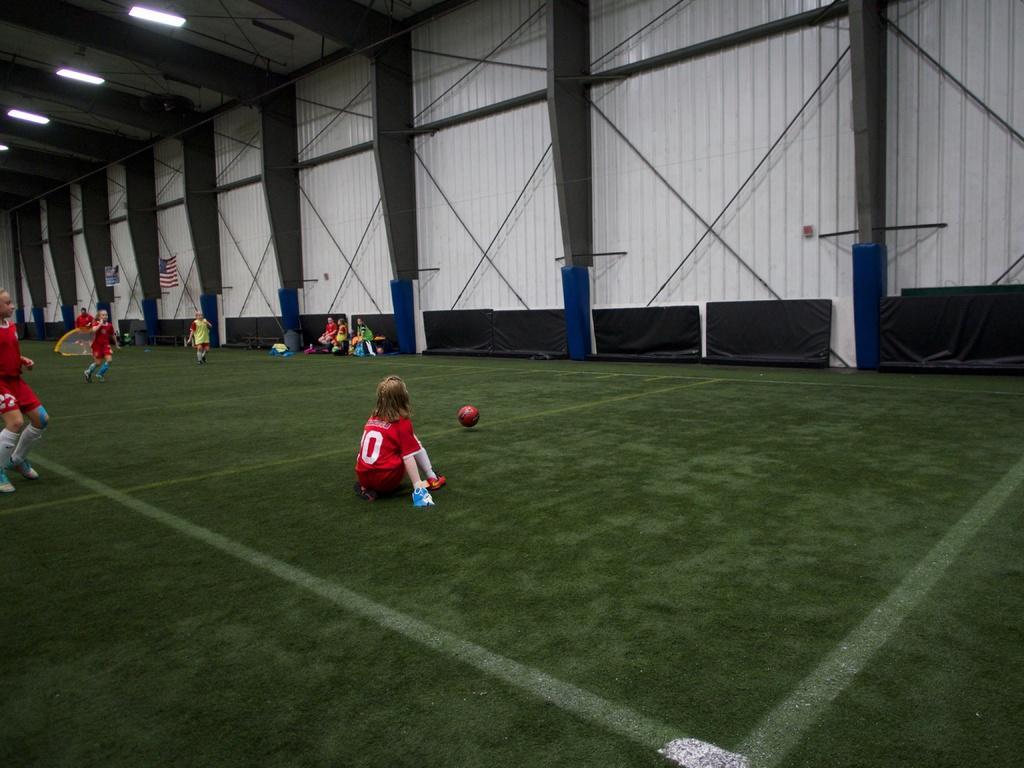Describe this image in one or two sentences. In this we can see a ground and girls are playing with ball. They are wearing red color dress. Background of the image wall are there which is in white color and flags are present. 